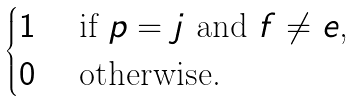Convert formula to latex. <formula><loc_0><loc_0><loc_500><loc_500>\begin{cases} 1 & \text { if $p=j$ and $f\neq e$,} \\ 0 & \text { otherwise. } \end{cases}</formula> 